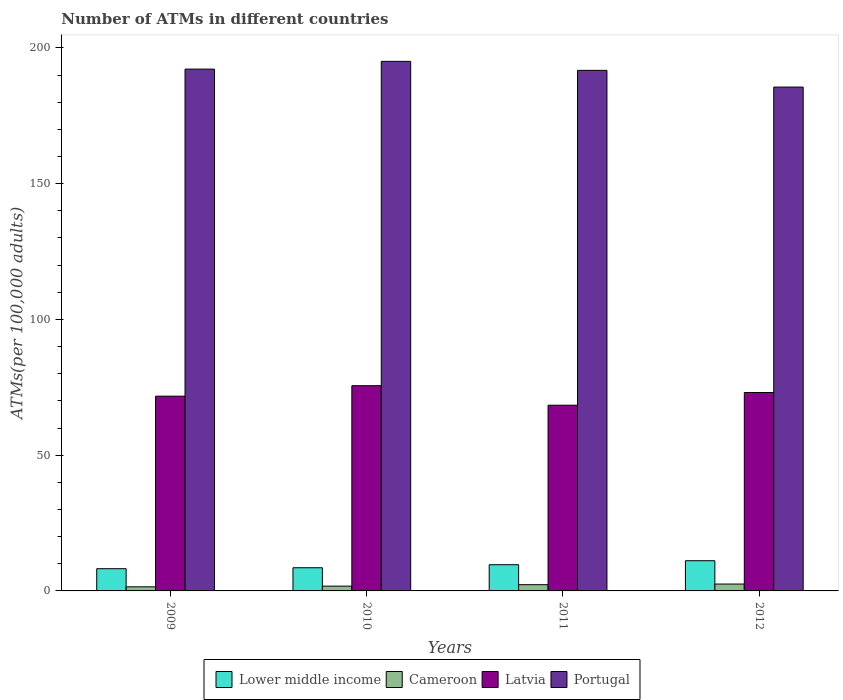How many different coloured bars are there?
Offer a very short reply. 4. How many groups of bars are there?
Your answer should be compact. 4. Are the number of bars on each tick of the X-axis equal?
Your answer should be compact. Yes. How many bars are there on the 1st tick from the left?
Give a very brief answer. 4. What is the label of the 4th group of bars from the left?
Give a very brief answer. 2012. What is the number of ATMs in Portugal in 2011?
Your response must be concise. 191.73. Across all years, what is the maximum number of ATMs in Portugal?
Your response must be concise. 195.04. Across all years, what is the minimum number of ATMs in Lower middle income?
Ensure brevity in your answer.  8.19. In which year was the number of ATMs in Cameroon maximum?
Provide a succinct answer. 2012. In which year was the number of ATMs in Cameroon minimum?
Ensure brevity in your answer.  2009. What is the total number of ATMs in Cameroon in the graph?
Make the answer very short. 8.11. What is the difference between the number of ATMs in Latvia in 2011 and that in 2012?
Provide a succinct answer. -4.68. What is the difference between the number of ATMs in Portugal in 2011 and the number of ATMs in Lower middle income in 2009?
Keep it short and to the point. 183.54. What is the average number of ATMs in Cameroon per year?
Offer a very short reply. 2.03. In the year 2011, what is the difference between the number of ATMs in Cameroon and number of ATMs in Latvia?
Ensure brevity in your answer.  -66.1. In how many years, is the number of ATMs in Lower middle income greater than 120?
Your answer should be compact. 0. What is the ratio of the number of ATMs in Lower middle income in 2009 to that in 2012?
Keep it short and to the point. 0.74. Is the number of ATMs in Latvia in 2010 less than that in 2011?
Offer a terse response. No. What is the difference between the highest and the second highest number of ATMs in Portugal?
Your answer should be very brief. 2.86. What is the difference between the highest and the lowest number of ATMs in Portugal?
Give a very brief answer. 9.47. In how many years, is the number of ATMs in Cameroon greater than the average number of ATMs in Cameroon taken over all years?
Keep it short and to the point. 2. Is it the case that in every year, the sum of the number of ATMs in Latvia and number of ATMs in Lower middle income is greater than the sum of number of ATMs in Cameroon and number of ATMs in Portugal?
Offer a terse response. No. What does the 3rd bar from the left in 2011 represents?
Your response must be concise. Latvia. What does the 3rd bar from the right in 2012 represents?
Ensure brevity in your answer.  Cameroon. Are all the bars in the graph horizontal?
Make the answer very short. No. How many years are there in the graph?
Offer a terse response. 4. Are the values on the major ticks of Y-axis written in scientific E-notation?
Your answer should be very brief. No. Does the graph contain grids?
Your response must be concise. No. Where does the legend appear in the graph?
Ensure brevity in your answer.  Bottom center. How many legend labels are there?
Your answer should be very brief. 4. What is the title of the graph?
Your answer should be very brief. Number of ATMs in different countries. Does "Nicaragua" appear as one of the legend labels in the graph?
Your answer should be compact. No. What is the label or title of the Y-axis?
Your answer should be very brief. ATMs(per 100,0 adults). What is the ATMs(per 100,000 adults) of Lower middle income in 2009?
Your response must be concise. 8.19. What is the ATMs(per 100,000 adults) of Cameroon in 2009?
Offer a very short reply. 1.51. What is the ATMs(per 100,000 adults) of Latvia in 2009?
Your answer should be compact. 71.73. What is the ATMs(per 100,000 adults) in Portugal in 2009?
Provide a succinct answer. 192.19. What is the ATMs(per 100,000 adults) of Lower middle income in 2010?
Offer a very short reply. 8.54. What is the ATMs(per 100,000 adults) of Cameroon in 2010?
Offer a terse response. 1.77. What is the ATMs(per 100,000 adults) of Latvia in 2010?
Ensure brevity in your answer.  75.58. What is the ATMs(per 100,000 adults) in Portugal in 2010?
Your answer should be very brief. 195.04. What is the ATMs(per 100,000 adults) of Lower middle income in 2011?
Your response must be concise. 9.65. What is the ATMs(per 100,000 adults) in Cameroon in 2011?
Give a very brief answer. 2.3. What is the ATMs(per 100,000 adults) of Latvia in 2011?
Offer a very short reply. 68.4. What is the ATMs(per 100,000 adults) in Portugal in 2011?
Ensure brevity in your answer.  191.73. What is the ATMs(per 100,000 adults) of Lower middle income in 2012?
Your answer should be compact. 11.13. What is the ATMs(per 100,000 adults) of Cameroon in 2012?
Keep it short and to the point. 2.53. What is the ATMs(per 100,000 adults) of Latvia in 2012?
Offer a very short reply. 73.08. What is the ATMs(per 100,000 adults) in Portugal in 2012?
Your answer should be very brief. 185.57. Across all years, what is the maximum ATMs(per 100,000 adults) in Lower middle income?
Your response must be concise. 11.13. Across all years, what is the maximum ATMs(per 100,000 adults) of Cameroon?
Provide a succinct answer. 2.53. Across all years, what is the maximum ATMs(per 100,000 adults) in Latvia?
Provide a succinct answer. 75.58. Across all years, what is the maximum ATMs(per 100,000 adults) of Portugal?
Provide a short and direct response. 195.04. Across all years, what is the minimum ATMs(per 100,000 adults) in Lower middle income?
Ensure brevity in your answer.  8.19. Across all years, what is the minimum ATMs(per 100,000 adults) in Cameroon?
Your answer should be compact. 1.51. Across all years, what is the minimum ATMs(per 100,000 adults) of Latvia?
Your response must be concise. 68.4. Across all years, what is the minimum ATMs(per 100,000 adults) of Portugal?
Your answer should be very brief. 185.57. What is the total ATMs(per 100,000 adults) in Lower middle income in the graph?
Your response must be concise. 37.51. What is the total ATMs(per 100,000 adults) in Cameroon in the graph?
Offer a terse response. 8.11. What is the total ATMs(per 100,000 adults) of Latvia in the graph?
Your answer should be compact. 288.79. What is the total ATMs(per 100,000 adults) of Portugal in the graph?
Give a very brief answer. 764.53. What is the difference between the ATMs(per 100,000 adults) of Lower middle income in 2009 and that in 2010?
Provide a succinct answer. -0.35. What is the difference between the ATMs(per 100,000 adults) in Cameroon in 2009 and that in 2010?
Make the answer very short. -0.26. What is the difference between the ATMs(per 100,000 adults) in Latvia in 2009 and that in 2010?
Make the answer very short. -3.85. What is the difference between the ATMs(per 100,000 adults) in Portugal in 2009 and that in 2010?
Provide a short and direct response. -2.86. What is the difference between the ATMs(per 100,000 adults) in Lower middle income in 2009 and that in 2011?
Your response must be concise. -1.46. What is the difference between the ATMs(per 100,000 adults) in Cameroon in 2009 and that in 2011?
Your answer should be very brief. -0.79. What is the difference between the ATMs(per 100,000 adults) of Latvia in 2009 and that in 2011?
Give a very brief answer. 3.33. What is the difference between the ATMs(per 100,000 adults) of Portugal in 2009 and that in 2011?
Provide a short and direct response. 0.46. What is the difference between the ATMs(per 100,000 adults) of Lower middle income in 2009 and that in 2012?
Your answer should be very brief. -2.94. What is the difference between the ATMs(per 100,000 adults) of Cameroon in 2009 and that in 2012?
Provide a succinct answer. -1.03. What is the difference between the ATMs(per 100,000 adults) in Latvia in 2009 and that in 2012?
Offer a terse response. -1.35. What is the difference between the ATMs(per 100,000 adults) in Portugal in 2009 and that in 2012?
Give a very brief answer. 6.62. What is the difference between the ATMs(per 100,000 adults) of Lower middle income in 2010 and that in 2011?
Offer a very short reply. -1.11. What is the difference between the ATMs(per 100,000 adults) of Cameroon in 2010 and that in 2011?
Provide a succinct answer. -0.53. What is the difference between the ATMs(per 100,000 adults) in Latvia in 2010 and that in 2011?
Keep it short and to the point. 7.19. What is the difference between the ATMs(per 100,000 adults) in Portugal in 2010 and that in 2011?
Your answer should be compact. 3.31. What is the difference between the ATMs(per 100,000 adults) of Lower middle income in 2010 and that in 2012?
Offer a very short reply. -2.59. What is the difference between the ATMs(per 100,000 adults) of Cameroon in 2010 and that in 2012?
Offer a terse response. -0.77. What is the difference between the ATMs(per 100,000 adults) in Latvia in 2010 and that in 2012?
Offer a very short reply. 2.51. What is the difference between the ATMs(per 100,000 adults) in Portugal in 2010 and that in 2012?
Offer a very short reply. 9.47. What is the difference between the ATMs(per 100,000 adults) of Lower middle income in 2011 and that in 2012?
Make the answer very short. -1.48. What is the difference between the ATMs(per 100,000 adults) in Cameroon in 2011 and that in 2012?
Make the answer very short. -0.24. What is the difference between the ATMs(per 100,000 adults) in Latvia in 2011 and that in 2012?
Your response must be concise. -4.68. What is the difference between the ATMs(per 100,000 adults) in Portugal in 2011 and that in 2012?
Your response must be concise. 6.16. What is the difference between the ATMs(per 100,000 adults) in Lower middle income in 2009 and the ATMs(per 100,000 adults) in Cameroon in 2010?
Keep it short and to the point. 6.42. What is the difference between the ATMs(per 100,000 adults) in Lower middle income in 2009 and the ATMs(per 100,000 adults) in Latvia in 2010?
Offer a very short reply. -67.4. What is the difference between the ATMs(per 100,000 adults) in Lower middle income in 2009 and the ATMs(per 100,000 adults) in Portugal in 2010?
Provide a succinct answer. -186.85. What is the difference between the ATMs(per 100,000 adults) in Cameroon in 2009 and the ATMs(per 100,000 adults) in Latvia in 2010?
Give a very brief answer. -74.08. What is the difference between the ATMs(per 100,000 adults) of Cameroon in 2009 and the ATMs(per 100,000 adults) of Portugal in 2010?
Offer a terse response. -193.54. What is the difference between the ATMs(per 100,000 adults) in Latvia in 2009 and the ATMs(per 100,000 adults) in Portugal in 2010?
Give a very brief answer. -123.31. What is the difference between the ATMs(per 100,000 adults) of Lower middle income in 2009 and the ATMs(per 100,000 adults) of Cameroon in 2011?
Provide a succinct answer. 5.89. What is the difference between the ATMs(per 100,000 adults) in Lower middle income in 2009 and the ATMs(per 100,000 adults) in Latvia in 2011?
Your response must be concise. -60.21. What is the difference between the ATMs(per 100,000 adults) in Lower middle income in 2009 and the ATMs(per 100,000 adults) in Portugal in 2011?
Offer a very short reply. -183.54. What is the difference between the ATMs(per 100,000 adults) in Cameroon in 2009 and the ATMs(per 100,000 adults) in Latvia in 2011?
Provide a succinct answer. -66.89. What is the difference between the ATMs(per 100,000 adults) in Cameroon in 2009 and the ATMs(per 100,000 adults) in Portugal in 2011?
Your answer should be compact. -190.22. What is the difference between the ATMs(per 100,000 adults) of Latvia in 2009 and the ATMs(per 100,000 adults) of Portugal in 2011?
Offer a terse response. -120. What is the difference between the ATMs(per 100,000 adults) in Lower middle income in 2009 and the ATMs(per 100,000 adults) in Cameroon in 2012?
Offer a very short reply. 5.65. What is the difference between the ATMs(per 100,000 adults) of Lower middle income in 2009 and the ATMs(per 100,000 adults) of Latvia in 2012?
Your answer should be very brief. -64.89. What is the difference between the ATMs(per 100,000 adults) in Lower middle income in 2009 and the ATMs(per 100,000 adults) in Portugal in 2012?
Ensure brevity in your answer.  -177.38. What is the difference between the ATMs(per 100,000 adults) of Cameroon in 2009 and the ATMs(per 100,000 adults) of Latvia in 2012?
Give a very brief answer. -71.57. What is the difference between the ATMs(per 100,000 adults) in Cameroon in 2009 and the ATMs(per 100,000 adults) in Portugal in 2012?
Offer a terse response. -184.06. What is the difference between the ATMs(per 100,000 adults) in Latvia in 2009 and the ATMs(per 100,000 adults) in Portugal in 2012?
Ensure brevity in your answer.  -113.84. What is the difference between the ATMs(per 100,000 adults) in Lower middle income in 2010 and the ATMs(per 100,000 adults) in Cameroon in 2011?
Your answer should be compact. 6.24. What is the difference between the ATMs(per 100,000 adults) in Lower middle income in 2010 and the ATMs(per 100,000 adults) in Latvia in 2011?
Your answer should be very brief. -59.86. What is the difference between the ATMs(per 100,000 adults) of Lower middle income in 2010 and the ATMs(per 100,000 adults) of Portugal in 2011?
Provide a short and direct response. -183.19. What is the difference between the ATMs(per 100,000 adults) of Cameroon in 2010 and the ATMs(per 100,000 adults) of Latvia in 2011?
Your response must be concise. -66.63. What is the difference between the ATMs(per 100,000 adults) of Cameroon in 2010 and the ATMs(per 100,000 adults) of Portugal in 2011?
Make the answer very short. -189.96. What is the difference between the ATMs(per 100,000 adults) of Latvia in 2010 and the ATMs(per 100,000 adults) of Portugal in 2011?
Offer a terse response. -116.15. What is the difference between the ATMs(per 100,000 adults) of Lower middle income in 2010 and the ATMs(per 100,000 adults) of Cameroon in 2012?
Your answer should be very brief. 6.01. What is the difference between the ATMs(per 100,000 adults) of Lower middle income in 2010 and the ATMs(per 100,000 adults) of Latvia in 2012?
Ensure brevity in your answer.  -64.54. What is the difference between the ATMs(per 100,000 adults) in Lower middle income in 2010 and the ATMs(per 100,000 adults) in Portugal in 2012?
Provide a succinct answer. -177.03. What is the difference between the ATMs(per 100,000 adults) of Cameroon in 2010 and the ATMs(per 100,000 adults) of Latvia in 2012?
Your response must be concise. -71.31. What is the difference between the ATMs(per 100,000 adults) in Cameroon in 2010 and the ATMs(per 100,000 adults) in Portugal in 2012?
Your response must be concise. -183.81. What is the difference between the ATMs(per 100,000 adults) in Latvia in 2010 and the ATMs(per 100,000 adults) in Portugal in 2012?
Provide a short and direct response. -109.99. What is the difference between the ATMs(per 100,000 adults) of Lower middle income in 2011 and the ATMs(per 100,000 adults) of Cameroon in 2012?
Offer a very short reply. 7.12. What is the difference between the ATMs(per 100,000 adults) in Lower middle income in 2011 and the ATMs(per 100,000 adults) in Latvia in 2012?
Offer a terse response. -63.42. What is the difference between the ATMs(per 100,000 adults) in Lower middle income in 2011 and the ATMs(per 100,000 adults) in Portugal in 2012?
Your answer should be compact. -175.92. What is the difference between the ATMs(per 100,000 adults) in Cameroon in 2011 and the ATMs(per 100,000 adults) in Latvia in 2012?
Give a very brief answer. -70.78. What is the difference between the ATMs(per 100,000 adults) of Cameroon in 2011 and the ATMs(per 100,000 adults) of Portugal in 2012?
Provide a succinct answer. -183.27. What is the difference between the ATMs(per 100,000 adults) in Latvia in 2011 and the ATMs(per 100,000 adults) in Portugal in 2012?
Give a very brief answer. -117.17. What is the average ATMs(per 100,000 adults) in Lower middle income per year?
Provide a succinct answer. 9.38. What is the average ATMs(per 100,000 adults) of Cameroon per year?
Provide a succinct answer. 2.03. What is the average ATMs(per 100,000 adults) in Latvia per year?
Offer a very short reply. 72.2. What is the average ATMs(per 100,000 adults) in Portugal per year?
Ensure brevity in your answer.  191.13. In the year 2009, what is the difference between the ATMs(per 100,000 adults) of Lower middle income and ATMs(per 100,000 adults) of Cameroon?
Your answer should be very brief. 6.68. In the year 2009, what is the difference between the ATMs(per 100,000 adults) of Lower middle income and ATMs(per 100,000 adults) of Latvia?
Give a very brief answer. -63.54. In the year 2009, what is the difference between the ATMs(per 100,000 adults) of Lower middle income and ATMs(per 100,000 adults) of Portugal?
Offer a very short reply. -184. In the year 2009, what is the difference between the ATMs(per 100,000 adults) of Cameroon and ATMs(per 100,000 adults) of Latvia?
Keep it short and to the point. -70.22. In the year 2009, what is the difference between the ATMs(per 100,000 adults) of Cameroon and ATMs(per 100,000 adults) of Portugal?
Your answer should be very brief. -190.68. In the year 2009, what is the difference between the ATMs(per 100,000 adults) of Latvia and ATMs(per 100,000 adults) of Portugal?
Offer a very short reply. -120.46. In the year 2010, what is the difference between the ATMs(per 100,000 adults) of Lower middle income and ATMs(per 100,000 adults) of Cameroon?
Ensure brevity in your answer.  6.77. In the year 2010, what is the difference between the ATMs(per 100,000 adults) of Lower middle income and ATMs(per 100,000 adults) of Latvia?
Your answer should be compact. -67.04. In the year 2010, what is the difference between the ATMs(per 100,000 adults) in Lower middle income and ATMs(per 100,000 adults) in Portugal?
Keep it short and to the point. -186.5. In the year 2010, what is the difference between the ATMs(per 100,000 adults) of Cameroon and ATMs(per 100,000 adults) of Latvia?
Offer a terse response. -73.82. In the year 2010, what is the difference between the ATMs(per 100,000 adults) of Cameroon and ATMs(per 100,000 adults) of Portugal?
Give a very brief answer. -193.28. In the year 2010, what is the difference between the ATMs(per 100,000 adults) in Latvia and ATMs(per 100,000 adults) in Portugal?
Your response must be concise. -119.46. In the year 2011, what is the difference between the ATMs(per 100,000 adults) in Lower middle income and ATMs(per 100,000 adults) in Cameroon?
Give a very brief answer. 7.35. In the year 2011, what is the difference between the ATMs(per 100,000 adults) in Lower middle income and ATMs(per 100,000 adults) in Latvia?
Offer a very short reply. -58.74. In the year 2011, what is the difference between the ATMs(per 100,000 adults) of Lower middle income and ATMs(per 100,000 adults) of Portugal?
Provide a succinct answer. -182.08. In the year 2011, what is the difference between the ATMs(per 100,000 adults) of Cameroon and ATMs(per 100,000 adults) of Latvia?
Ensure brevity in your answer.  -66.1. In the year 2011, what is the difference between the ATMs(per 100,000 adults) in Cameroon and ATMs(per 100,000 adults) in Portugal?
Offer a terse response. -189.43. In the year 2011, what is the difference between the ATMs(per 100,000 adults) of Latvia and ATMs(per 100,000 adults) of Portugal?
Ensure brevity in your answer.  -123.33. In the year 2012, what is the difference between the ATMs(per 100,000 adults) in Lower middle income and ATMs(per 100,000 adults) in Cameroon?
Your answer should be very brief. 8.59. In the year 2012, what is the difference between the ATMs(per 100,000 adults) of Lower middle income and ATMs(per 100,000 adults) of Latvia?
Offer a terse response. -61.95. In the year 2012, what is the difference between the ATMs(per 100,000 adults) in Lower middle income and ATMs(per 100,000 adults) in Portugal?
Give a very brief answer. -174.44. In the year 2012, what is the difference between the ATMs(per 100,000 adults) of Cameroon and ATMs(per 100,000 adults) of Latvia?
Offer a terse response. -70.54. In the year 2012, what is the difference between the ATMs(per 100,000 adults) of Cameroon and ATMs(per 100,000 adults) of Portugal?
Give a very brief answer. -183.04. In the year 2012, what is the difference between the ATMs(per 100,000 adults) of Latvia and ATMs(per 100,000 adults) of Portugal?
Offer a terse response. -112.49. What is the ratio of the ATMs(per 100,000 adults) of Lower middle income in 2009 to that in 2010?
Offer a terse response. 0.96. What is the ratio of the ATMs(per 100,000 adults) of Cameroon in 2009 to that in 2010?
Provide a short and direct response. 0.85. What is the ratio of the ATMs(per 100,000 adults) in Latvia in 2009 to that in 2010?
Offer a terse response. 0.95. What is the ratio of the ATMs(per 100,000 adults) in Portugal in 2009 to that in 2010?
Your response must be concise. 0.99. What is the ratio of the ATMs(per 100,000 adults) in Lower middle income in 2009 to that in 2011?
Provide a succinct answer. 0.85. What is the ratio of the ATMs(per 100,000 adults) of Cameroon in 2009 to that in 2011?
Your answer should be very brief. 0.66. What is the ratio of the ATMs(per 100,000 adults) in Latvia in 2009 to that in 2011?
Your answer should be very brief. 1.05. What is the ratio of the ATMs(per 100,000 adults) of Portugal in 2009 to that in 2011?
Your response must be concise. 1. What is the ratio of the ATMs(per 100,000 adults) of Lower middle income in 2009 to that in 2012?
Your answer should be compact. 0.74. What is the ratio of the ATMs(per 100,000 adults) of Cameroon in 2009 to that in 2012?
Your answer should be very brief. 0.59. What is the ratio of the ATMs(per 100,000 adults) in Latvia in 2009 to that in 2012?
Ensure brevity in your answer.  0.98. What is the ratio of the ATMs(per 100,000 adults) in Portugal in 2009 to that in 2012?
Give a very brief answer. 1.04. What is the ratio of the ATMs(per 100,000 adults) of Lower middle income in 2010 to that in 2011?
Provide a succinct answer. 0.88. What is the ratio of the ATMs(per 100,000 adults) of Cameroon in 2010 to that in 2011?
Give a very brief answer. 0.77. What is the ratio of the ATMs(per 100,000 adults) in Latvia in 2010 to that in 2011?
Keep it short and to the point. 1.11. What is the ratio of the ATMs(per 100,000 adults) of Portugal in 2010 to that in 2011?
Give a very brief answer. 1.02. What is the ratio of the ATMs(per 100,000 adults) in Lower middle income in 2010 to that in 2012?
Give a very brief answer. 0.77. What is the ratio of the ATMs(per 100,000 adults) in Cameroon in 2010 to that in 2012?
Provide a short and direct response. 0.7. What is the ratio of the ATMs(per 100,000 adults) of Latvia in 2010 to that in 2012?
Your response must be concise. 1.03. What is the ratio of the ATMs(per 100,000 adults) in Portugal in 2010 to that in 2012?
Keep it short and to the point. 1.05. What is the ratio of the ATMs(per 100,000 adults) of Lower middle income in 2011 to that in 2012?
Keep it short and to the point. 0.87. What is the ratio of the ATMs(per 100,000 adults) in Cameroon in 2011 to that in 2012?
Provide a short and direct response. 0.91. What is the ratio of the ATMs(per 100,000 adults) of Latvia in 2011 to that in 2012?
Make the answer very short. 0.94. What is the ratio of the ATMs(per 100,000 adults) in Portugal in 2011 to that in 2012?
Offer a very short reply. 1.03. What is the difference between the highest and the second highest ATMs(per 100,000 adults) in Lower middle income?
Give a very brief answer. 1.48. What is the difference between the highest and the second highest ATMs(per 100,000 adults) of Cameroon?
Provide a short and direct response. 0.24. What is the difference between the highest and the second highest ATMs(per 100,000 adults) of Latvia?
Offer a terse response. 2.51. What is the difference between the highest and the second highest ATMs(per 100,000 adults) of Portugal?
Your answer should be very brief. 2.86. What is the difference between the highest and the lowest ATMs(per 100,000 adults) in Lower middle income?
Ensure brevity in your answer.  2.94. What is the difference between the highest and the lowest ATMs(per 100,000 adults) of Cameroon?
Ensure brevity in your answer.  1.03. What is the difference between the highest and the lowest ATMs(per 100,000 adults) in Latvia?
Provide a succinct answer. 7.19. What is the difference between the highest and the lowest ATMs(per 100,000 adults) in Portugal?
Ensure brevity in your answer.  9.47. 